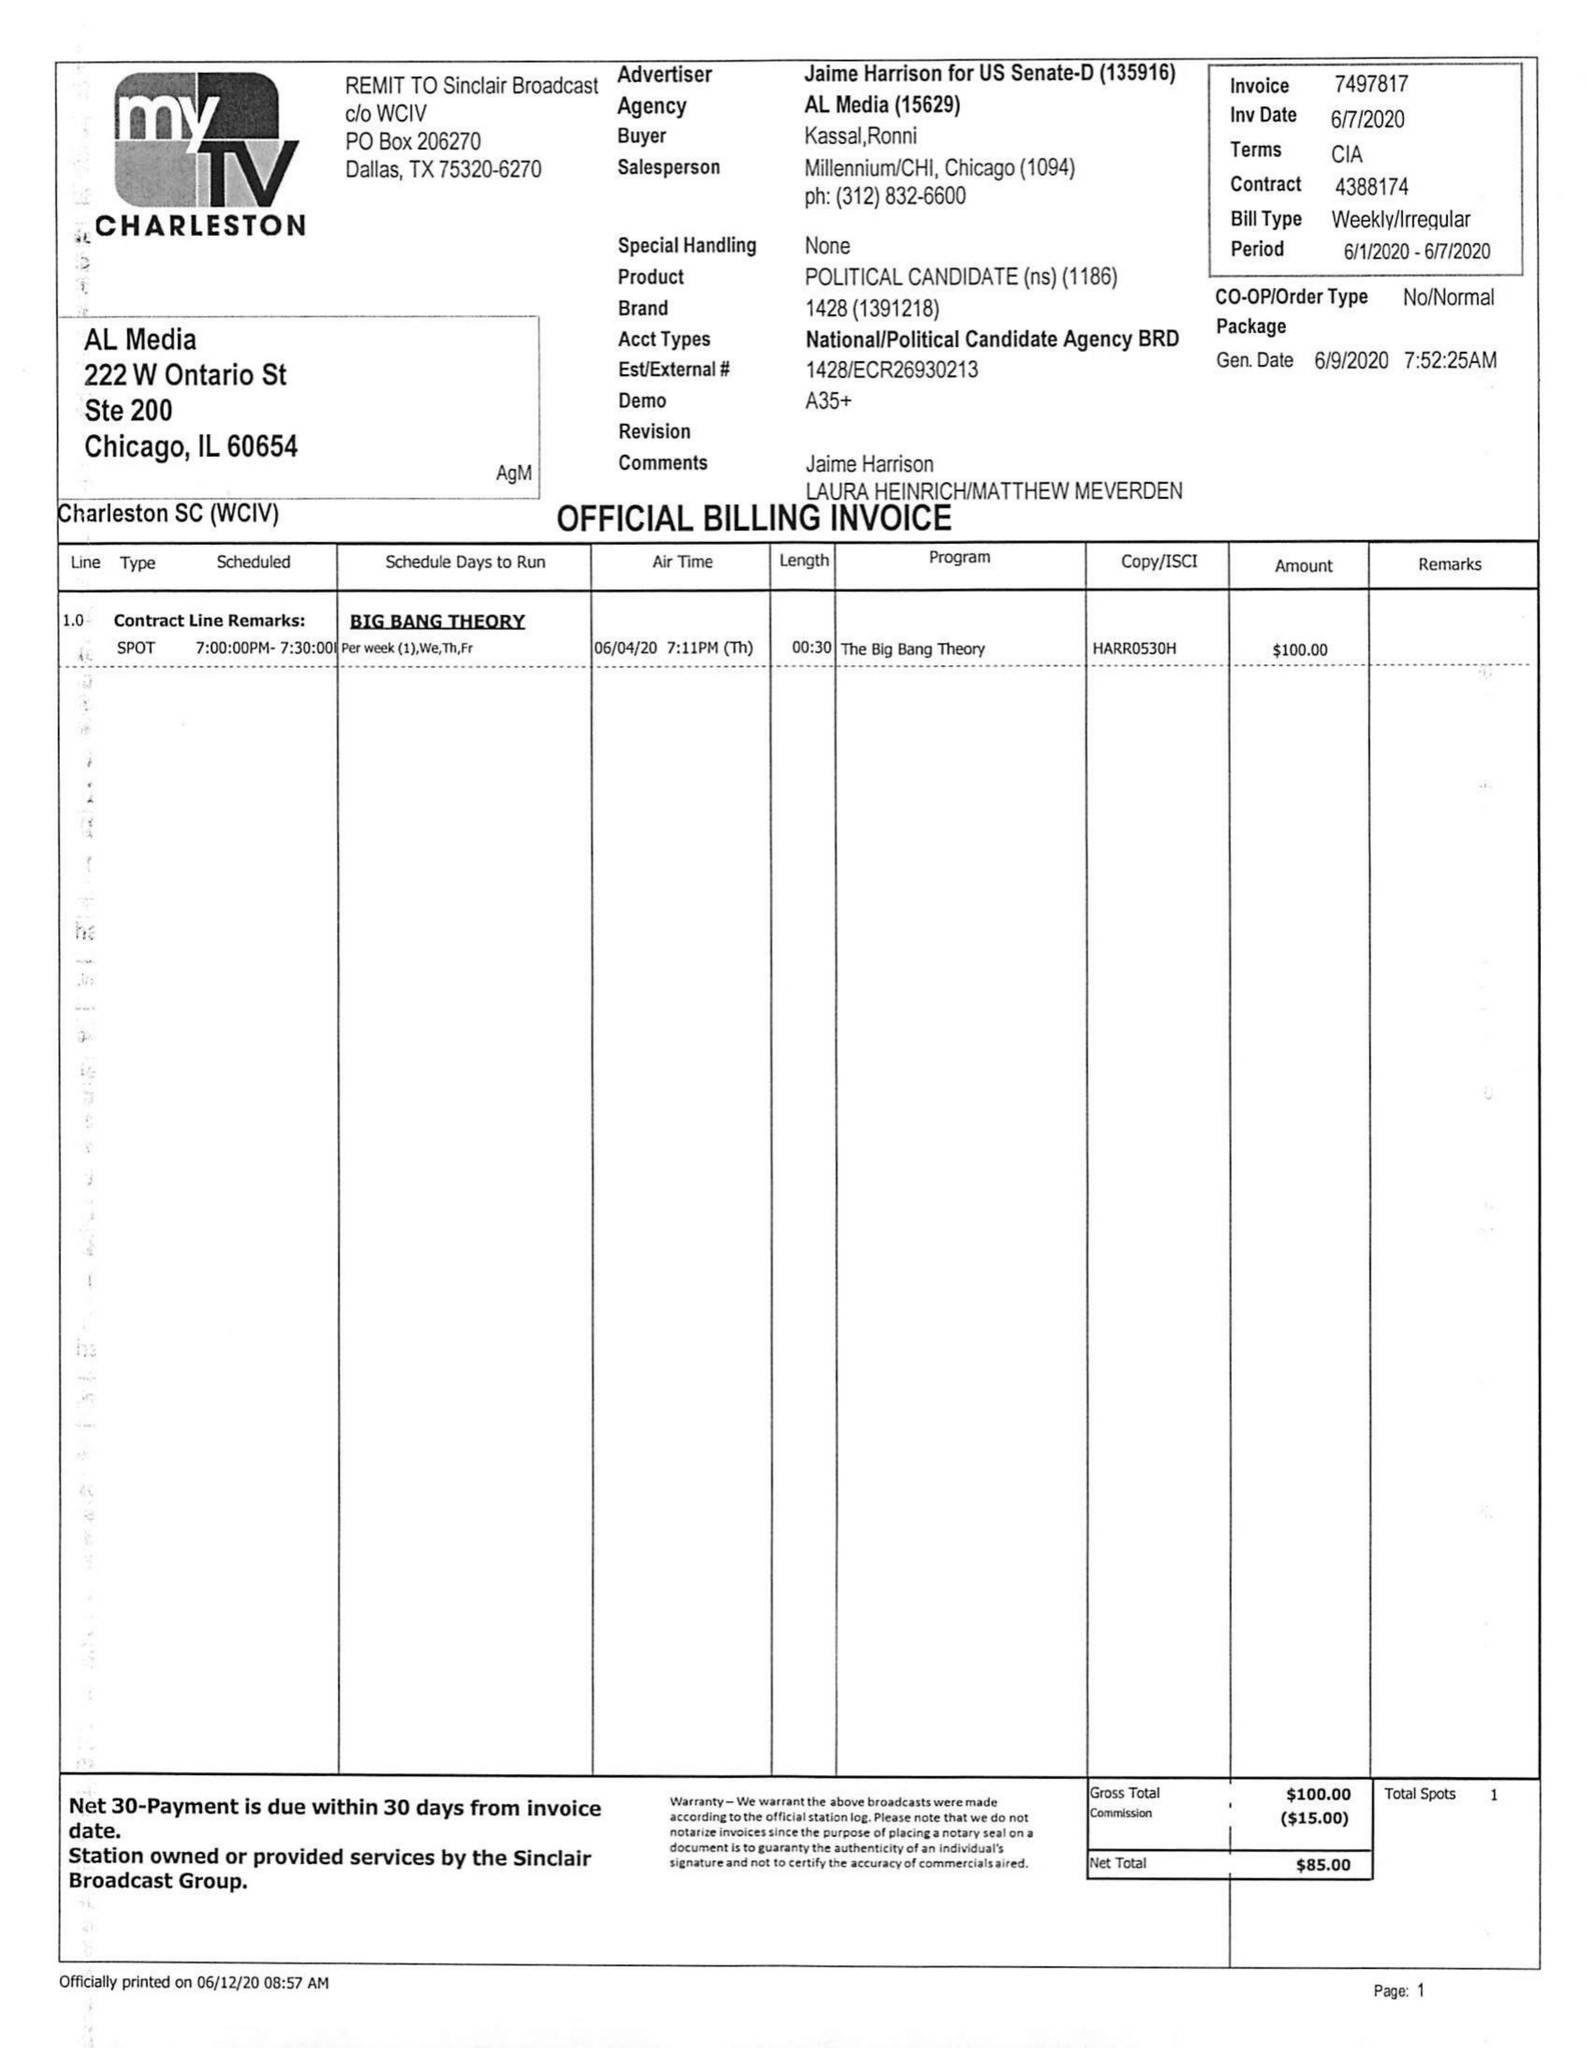What is the value for the contract_num?
Answer the question using a single word or phrase. 4388174 